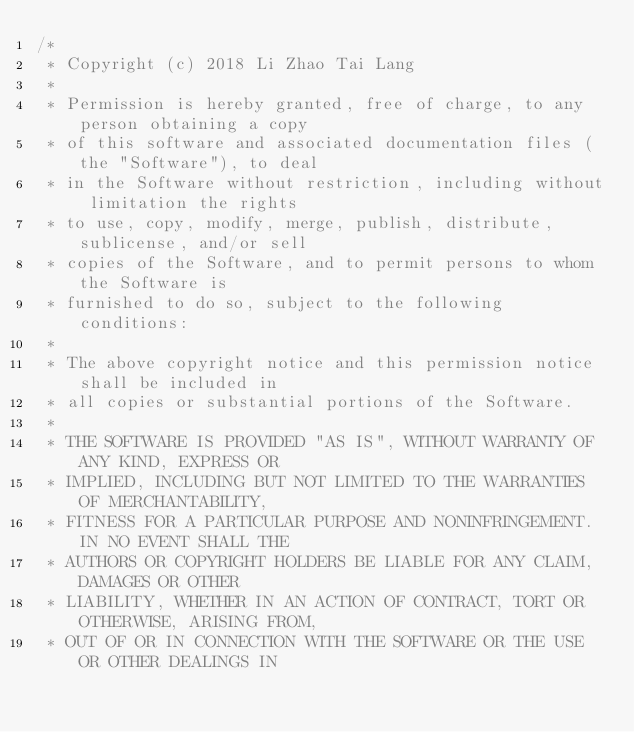Convert code to text. <code><loc_0><loc_0><loc_500><loc_500><_Kotlin_>/*
 * Copyright (c) 2018 Li Zhao Tai Lang
 *
 * Permission is hereby granted, free of charge, to any person obtaining a copy
 * of this software and associated documentation files (the "Software"), to deal
 * in the Software without restriction, including without limitation the rights
 * to use, copy, modify, merge, publish, distribute, sublicense, and/or sell
 * copies of the Software, and to permit persons to whom the Software is
 * furnished to do so, subject to the following conditions:
 *
 * The above copyright notice and this permission notice shall be included in
 * all copies or substantial portions of the Software.
 *
 * THE SOFTWARE IS PROVIDED "AS IS", WITHOUT WARRANTY OF ANY KIND, EXPRESS OR
 * IMPLIED, INCLUDING BUT NOT LIMITED TO THE WARRANTIES OF MERCHANTABILITY,
 * FITNESS FOR A PARTICULAR PURPOSE AND NONINFRINGEMENT. IN NO EVENT SHALL THE
 * AUTHORS OR COPYRIGHT HOLDERS BE LIABLE FOR ANY CLAIM, DAMAGES OR OTHER
 * LIABILITY, WHETHER IN AN ACTION OF CONTRACT, TORT OR OTHERWISE, ARISING FROM,
 * OUT OF OR IN CONNECTION WITH THE SOFTWARE OR THE USE OR OTHER DEALINGS IN</code> 